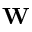Convert formula to latex. <formula><loc_0><loc_0><loc_500><loc_500>W</formula> 